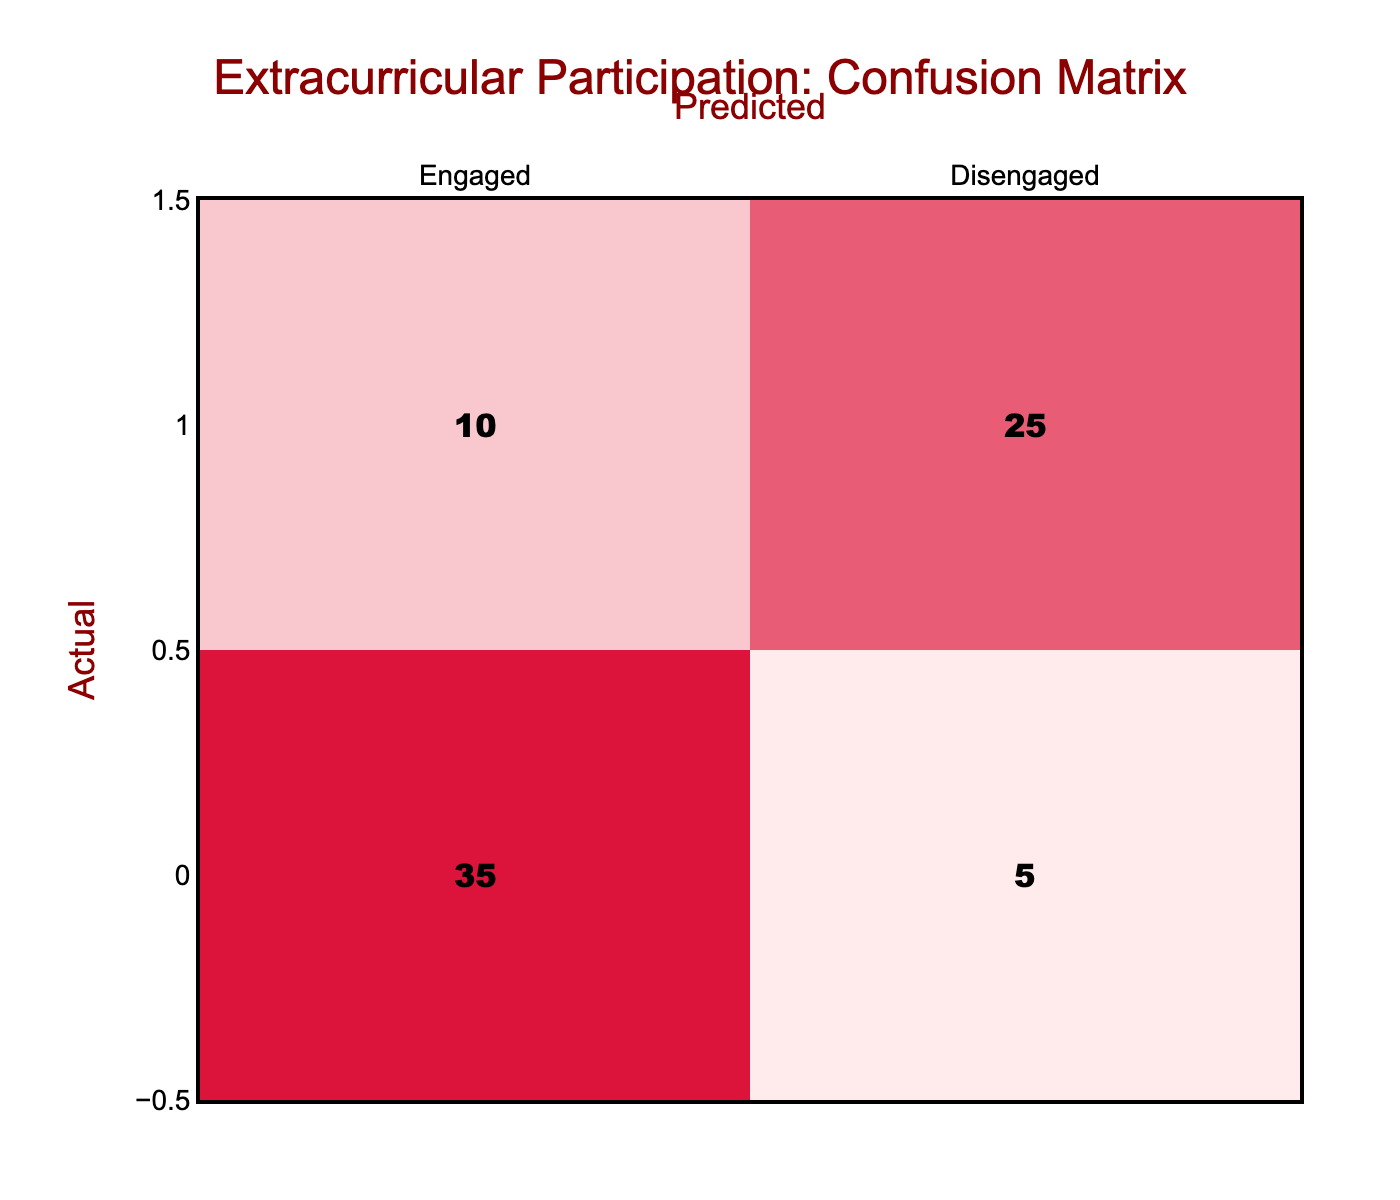What is the number of students who were correctly predicted as engaged? The table shows that 35 students were correctly predicted as engaged, which is directly taken from the "Engaged" row under the "Engaged" column.
Answer: 35 What is the number of students who were incorrectly predicted as disengaged? The number of students who were incorrectly predicted as disengaged corresponds to the "Disengaged" row under the "Engaged" column, which is 10.
Answer: 10 What is the total number of engaged students in the actual data? The total number of engaged students can be calculated by summing the values in the "Engaged" row, which are 35 (correctly predicted) + 5 (incorrectly predicted) = 40.
Answer: 40 How many students were predicted as disengaged but were actually engaged? This value refers to the number in the "Engaged" row under the "Disengaged" column, which is 5.
Answer: 5 Is it true that more students were correctly predicted as disengaged than engaged? To evaluate, we compare the numbers: 25 (correctly predicted disengaged) and 35 (correctly predicted engaged). Since 25 is less than 35, the statement is false.
Answer: No What is the percentage of students who were correctly predicted as engaged out of the total engaged students? The percentage is calculated by dividing the number of correctly predicted engaged students (35) by the total number of engaged students (40), then multiplying by 100: (35/40) * 100 = 87.5%.
Answer: 87.5% What is the total number of disengaged students in the actual data? The total disengaged students can be found by summing the values in the "Disengaged" row: 10 (incorrectly predicted) + 25 (correctly predicted) = 35.
Answer: 35 What is the number of students who were correctly predicted as either category? This total is calculated by adding the number of correctly predicted engaged (35) and disengaged (25): 35 + 25 = 60.
Answer: 60 If we combine both rows, what is the total number of students studied in this confusion matrix? The total is the sum of all four values in the table: 35 (Engaged/Engaged) + 5 (Engaged/Disengaged) + 10 (Disengaged/Engaged) + 25 (Disengaged/Disengaged) = 75.
Answer: 75 